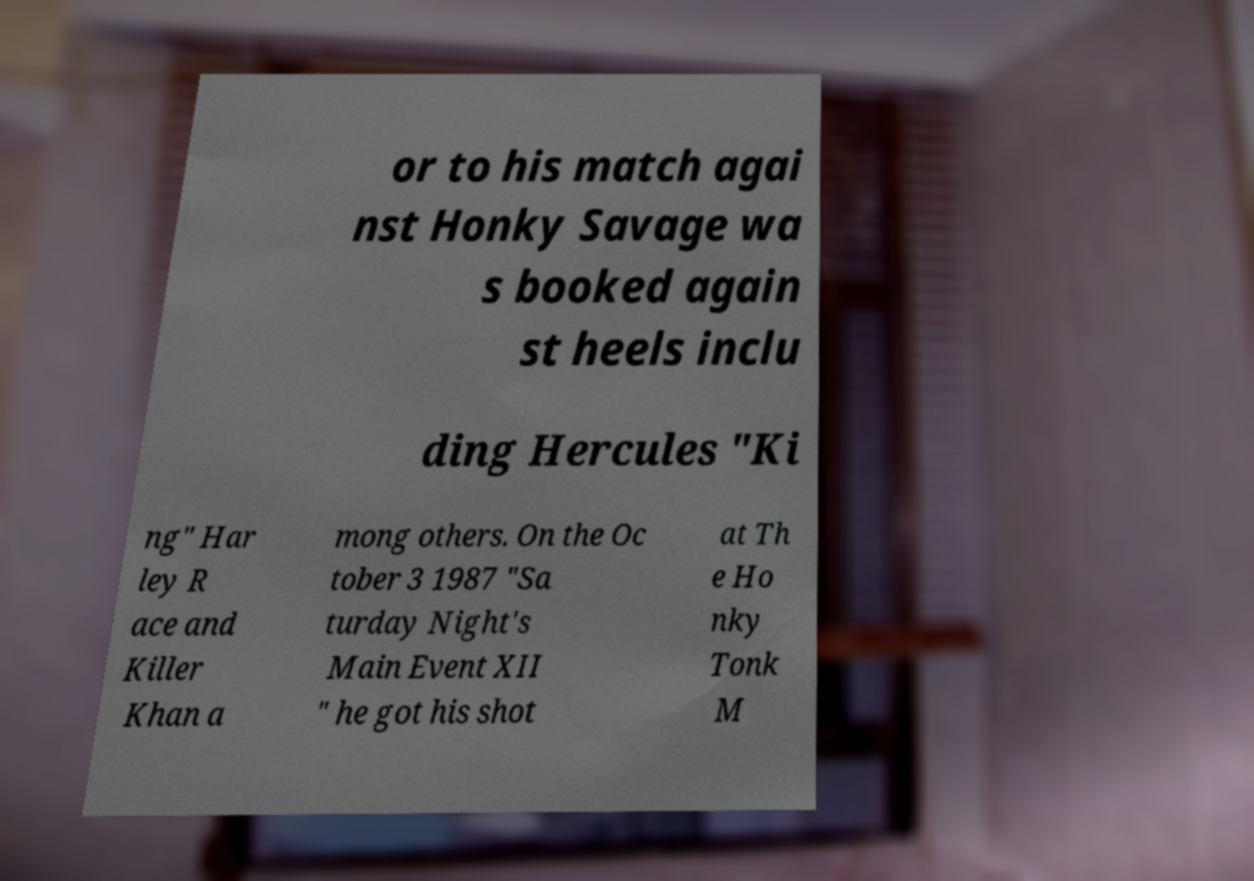There's text embedded in this image that I need extracted. Can you transcribe it verbatim? or to his match agai nst Honky Savage wa s booked again st heels inclu ding Hercules "Ki ng" Har ley R ace and Killer Khan a mong others. On the Oc tober 3 1987 "Sa turday Night's Main Event XII " he got his shot at Th e Ho nky Tonk M 